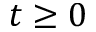Convert formula to latex. <formula><loc_0><loc_0><loc_500><loc_500>t \geq 0</formula> 